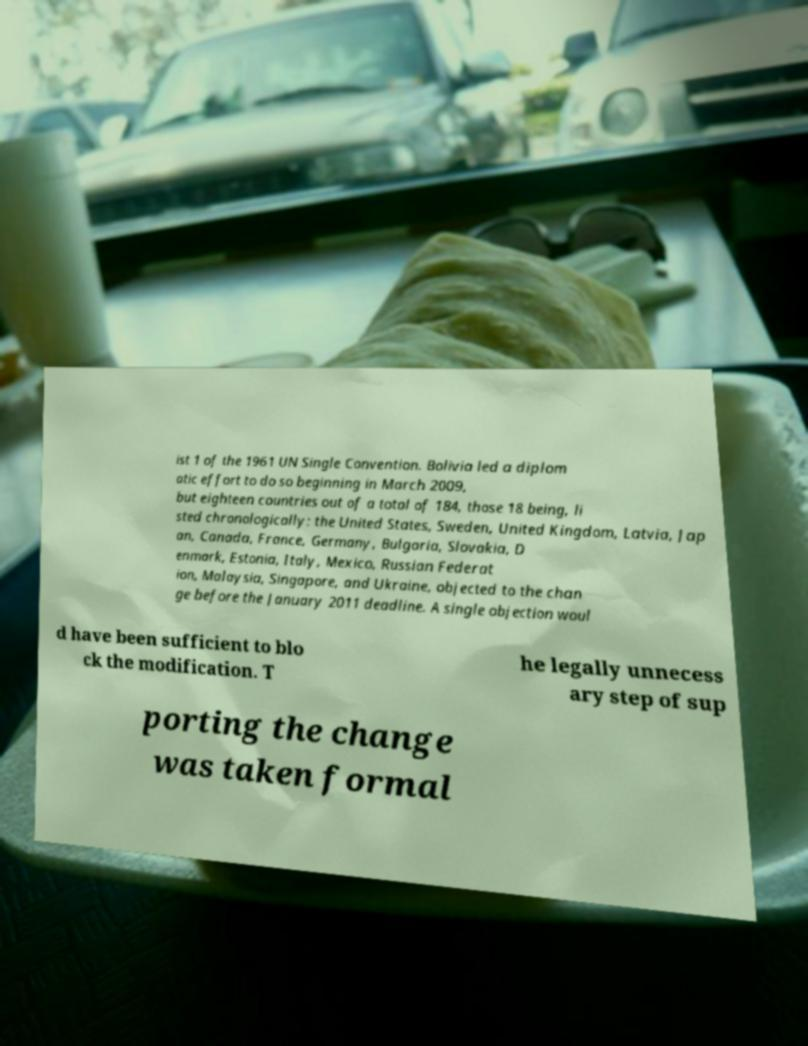There's text embedded in this image that I need extracted. Can you transcribe it verbatim? ist 1 of the 1961 UN Single Convention. Bolivia led a diplom atic effort to do so beginning in March 2009, but eighteen countries out of a total of 184, those 18 being, li sted chronologically: the United States, Sweden, United Kingdom, Latvia, Jap an, Canada, France, Germany, Bulgaria, Slovakia, D enmark, Estonia, Italy, Mexico, Russian Federat ion, Malaysia, Singapore, and Ukraine, objected to the chan ge before the January 2011 deadline. A single objection woul d have been sufficient to blo ck the modification. T he legally unnecess ary step of sup porting the change was taken formal 